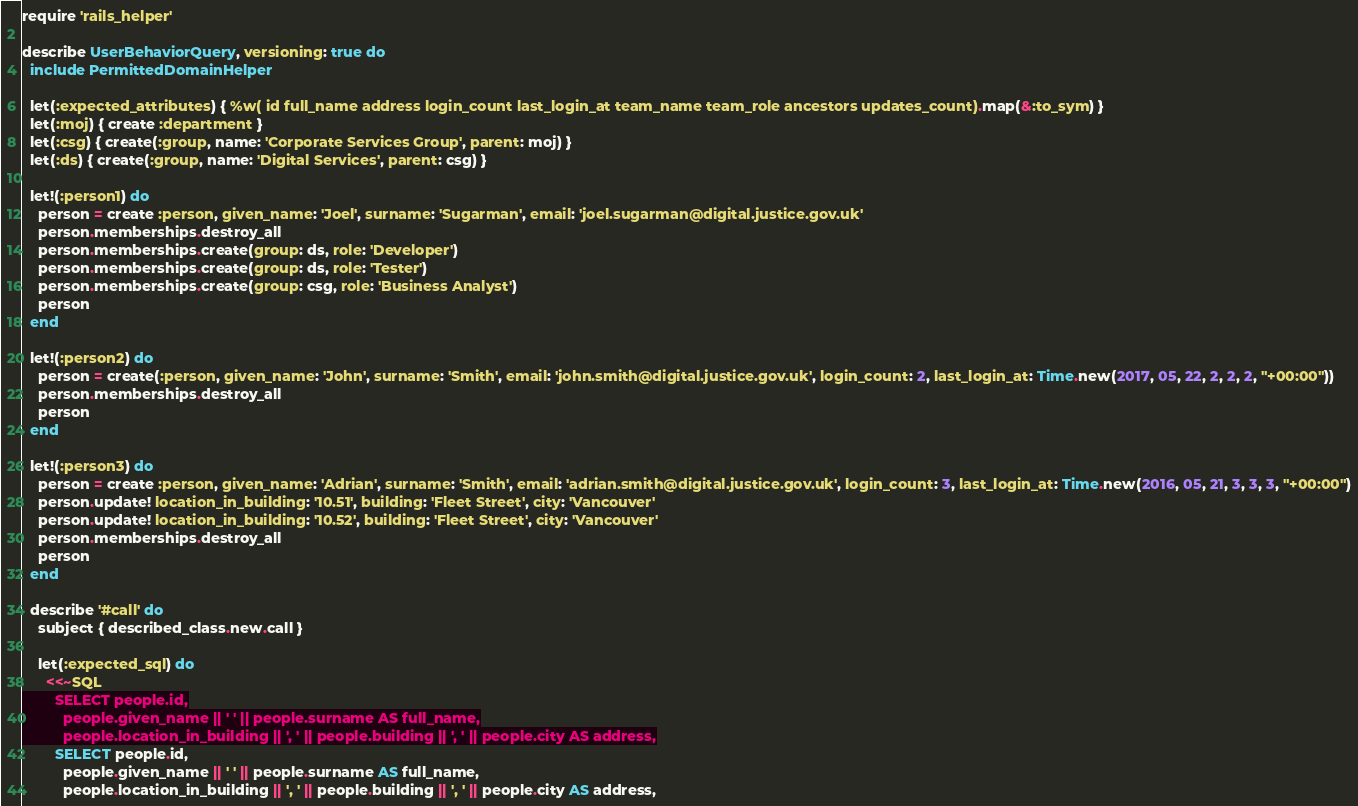<code> <loc_0><loc_0><loc_500><loc_500><_Ruby_>require 'rails_helper'

describe UserBehaviorQuery, versioning: true do
  include PermittedDomainHelper

  let(:expected_attributes) { %w( id full_name address login_count last_login_at team_name team_role ancestors updates_count).map(&:to_sym) }
  let(:moj) { create :department }
  let(:csg) { create(:group, name: 'Corporate Services Group', parent: moj) }
  let(:ds) { create(:group, name: 'Digital Services', parent: csg) }

  let!(:person1) do
    person = create :person, given_name: 'Joel', surname: 'Sugarman', email: 'joel.sugarman@digital.justice.gov.uk'
    person.memberships.destroy_all
    person.memberships.create(group: ds, role: 'Developer')
    person.memberships.create(group: ds, role: 'Tester')
    person.memberships.create(group: csg, role: 'Business Analyst')
    person
  end

  let!(:person2) do
    person = create(:person, given_name: 'John', surname: 'Smith', email: 'john.smith@digital.justice.gov.uk', login_count: 2, last_login_at: Time.new(2017, 05, 22, 2, 2, 2, "+00:00"))
    person.memberships.destroy_all
    person
  end

  let!(:person3) do
    person = create :person, given_name: 'Adrian', surname: 'Smith', email: 'adrian.smith@digital.justice.gov.uk', login_count: 3, last_login_at: Time.new(2016, 05, 21, 3, 3, 3, "+00:00")
    person.update! location_in_building: '10.51', building: 'Fleet Street', city: 'Vancouver'
    person.update! location_in_building: '10.52', building: 'Fleet Street', city: 'Vancouver'
    person.memberships.destroy_all
    person
  end

  describe '#call' do
    subject { described_class.new.call }

    let(:expected_sql) do
      <<~SQL
        SELECT people.id,
          people.given_name || ' ' || people.surname AS full_name,
          people.location_in_building || ', ' || people.building || ', ' || people.city AS address,</code> 